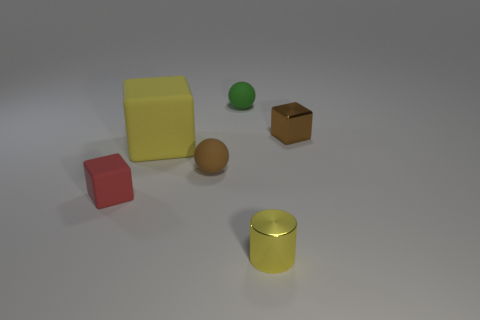Which object in the image is the largest? The largest object in the image is the yellow cube. Its volume is visibly greater than that of the other objects present in the scene. What purposes do images like this serve in computer graphics? Images like this serve multiple purposes in computer graphics: they can be used for teaching basic 3D modeling and rendering, fine-tuning graphics engines, testing how different textures look under various lighting conditions, and in software benchmarks to assess performance across different rendering techniques. 